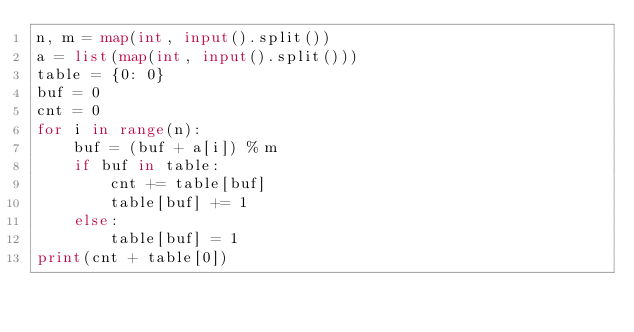<code> <loc_0><loc_0><loc_500><loc_500><_Python_>n, m = map(int, input().split())
a = list(map(int, input().split()))
table = {0: 0}
buf = 0
cnt = 0
for i in range(n):
    buf = (buf + a[i]) % m
    if buf in table:
        cnt += table[buf]
        table[buf] += 1
    else:
        table[buf] = 1
print(cnt + table[0])</code> 